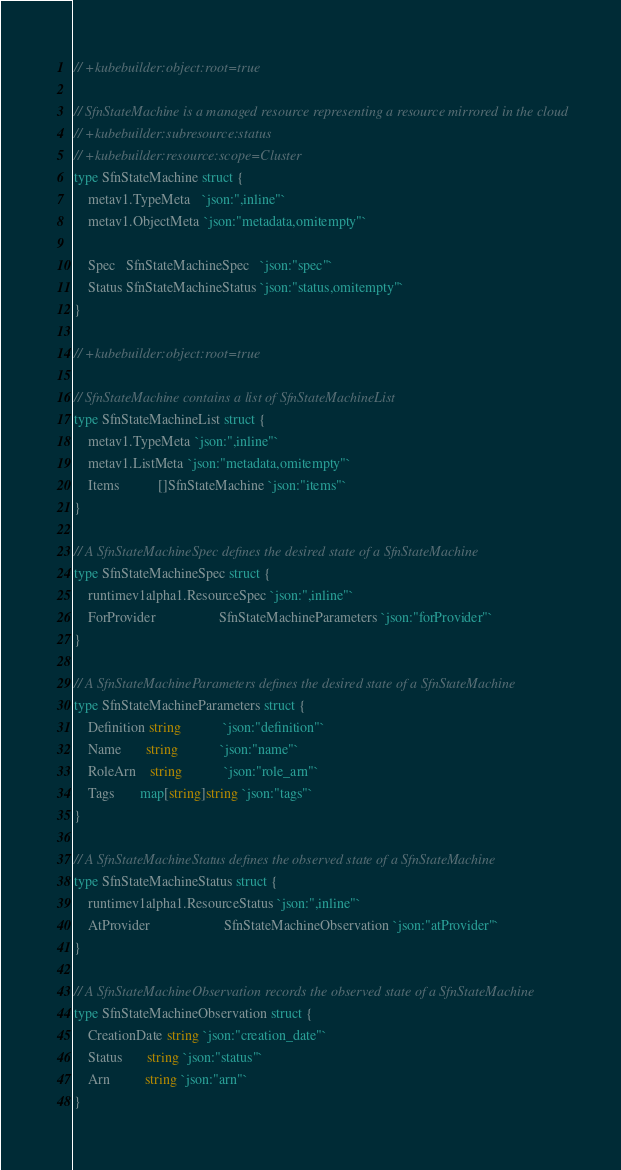<code> <loc_0><loc_0><loc_500><loc_500><_Go_>// +kubebuilder:object:root=true

// SfnStateMachine is a managed resource representing a resource mirrored in the cloud
// +kubebuilder:subresource:status
// +kubebuilder:resource:scope=Cluster
type SfnStateMachine struct {
	metav1.TypeMeta   `json:",inline"`
	metav1.ObjectMeta `json:"metadata,omitempty"`

	Spec   SfnStateMachineSpec   `json:"spec"`
	Status SfnStateMachineStatus `json:"status,omitempty"`
}

// +kubebuilder:object:root=true

// SfnStateMachine contains a list of SfnStateMachineList
type SfnStateMachineList struct {
	metav1.TypeMeta `json:",inline"`
	metav1.ListMeta `json:"metadata,omitempty"`
	Items           []SfnStateMachine `json:"items"`
}

// A SfnStateMachineSpec defines the desired state of a SfnStateMachine
type SfnStateMachineSpec struct {
	runtimev1alpha1.ResourceSpec `json:",inline"`
	ForProvider                  SfnStateMachineParameters `json:"forProvider"`
}

// A SfnStateMachineParameters defines the desired state of a SfnStateMachine
type SfnStateMachineParameters struct {
	Definition string            `json:"definition"`
	Name       string            `json:"name"`
	RoleArn    string            `json:"role_arn"`
	Tags       map[string]string `json:"tags"`
}

// A SfnStateMachineStatus defines the observed state of a SfnStateMachine
type SfnStateMachineStatus struct {
	runtimev1alpha1.ResourceStatus `json:",inline"`
	AtProvider                     SfnStateMachineObservation `json:"atProvider"`
}

// A SfnStateMachineObservation records the observed state of a SfnStateMachine
type SfnStateMachineObservation struct {
	CreationDate string `json:"creation_date"`
	Status       string `json:"status"`
	Arn          string `json:"arn"`
}</code> 